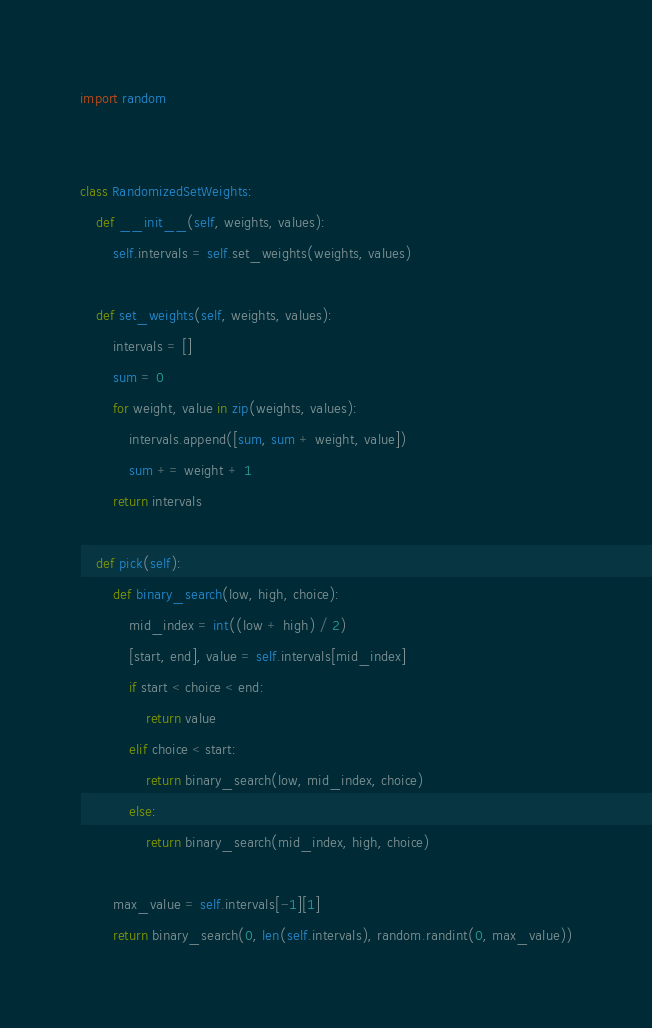<code> <loc_0><loc_0><loc_500><loc_500><_Python_>import random


class RandomizedSetWeights:
    def __init__(self, weights, values):
        self.intervals = self.set_weights(weights, values)

    def set_weights(self, weights, values):
        intervals = []
        sum = 0
        for weight, value in zip(weights, values):
            intervals.append([sum, sum + weight, value])
            sum += weight + 1
        return intervals

    def pick(self):
        def binary_search(low, high, choice):
            mid_index = int((low + high) / 2)
            [start, end], value = self.intervals[mid_index]
            if start < choice < end:
                return value
            elif choice < start:
                return binary_search(low, mid_index, choice)
            else:
                return binary_search(mid_index, high, choice)

        max_value = self.intervals[-1][1]
        return binary_search(0, len(self.intervals), random.randint(0, max_value))
</code> 